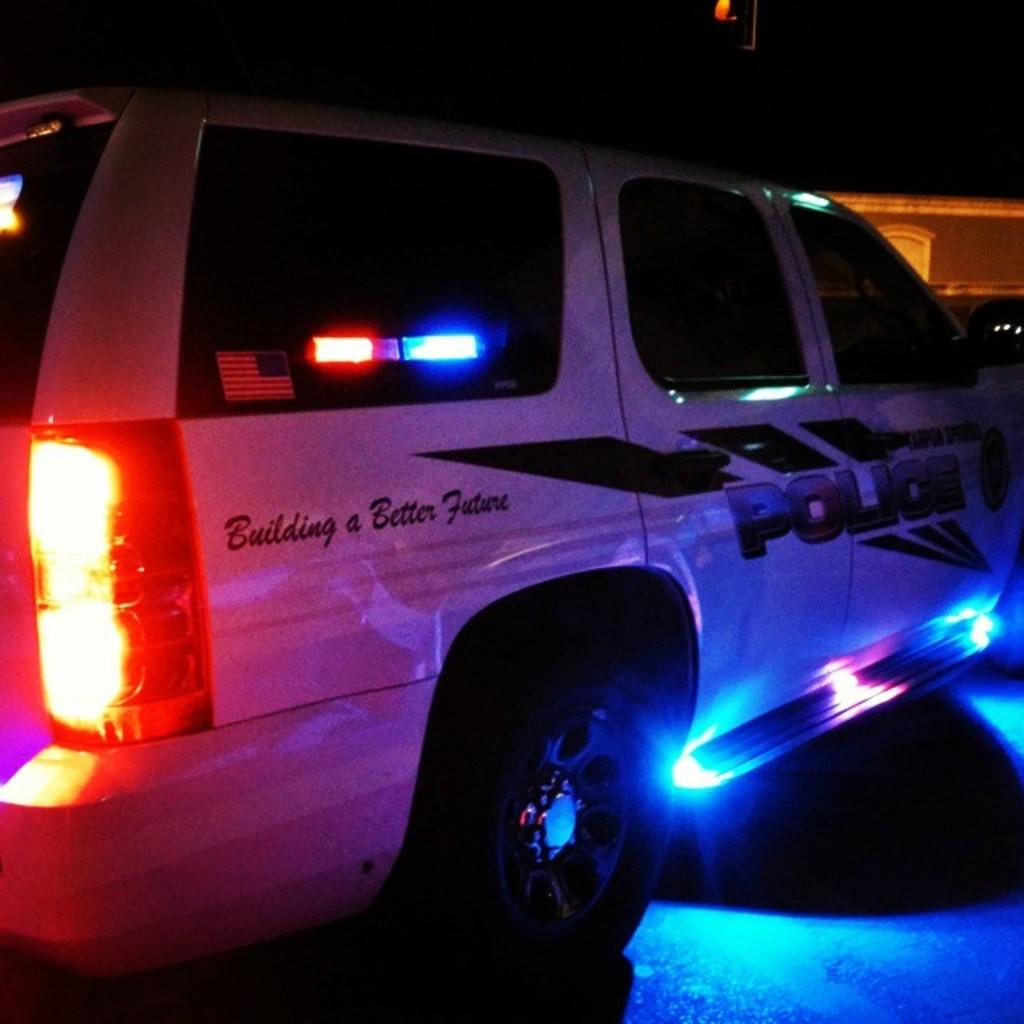What is the main subject of the image? The main subject of the image is a vehicle. What feature does the vehicle have? The vehicle has lights. Is there any text or symbols on the vehicle? Yes, there is writing on the vehicle. What can be observed about the background of the image? The background of the image is dark. How does the wind affect the branch in the image? There is no branch present in the image; it only features a vehicle with lights and writing. 